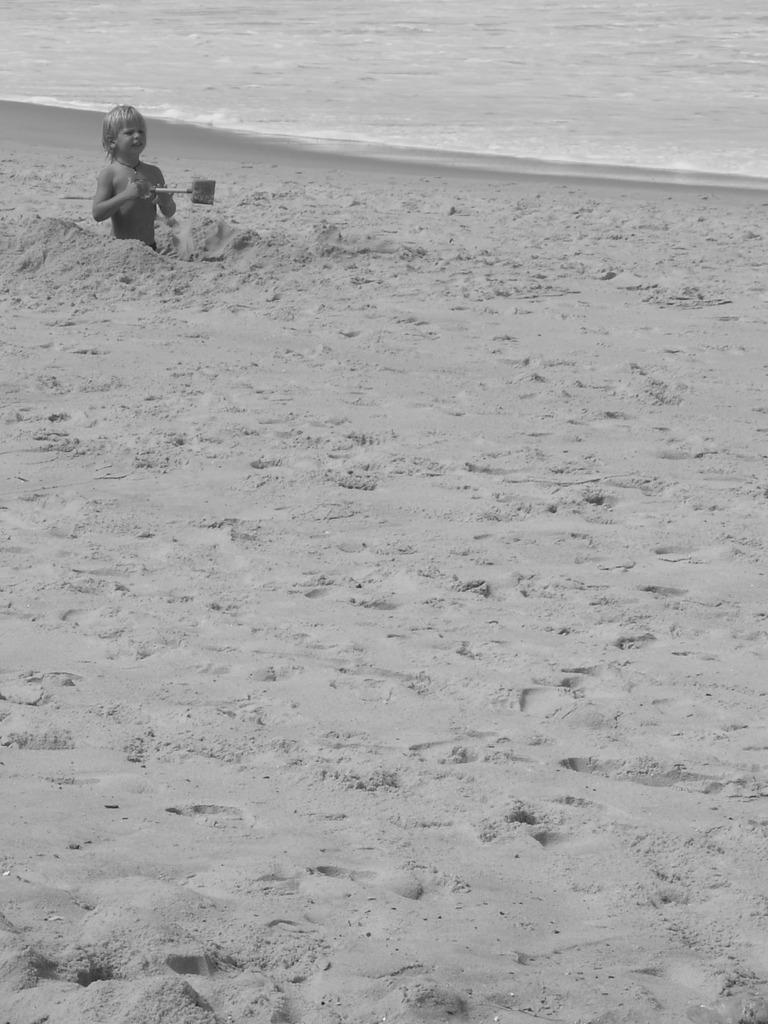Who is the main subject in the image? There is a boy in the image. What is the boy doing in the image? The boy is holding an object. What can be seen in the background of the image? There is water visible in the background of the image. What is the color scheme of the image? The image is black and white in color. What type of business is the boy celebrating his birthday at in the image? There is no indication of a business or a birthday celebration in the image; it features a boy holding an object in a black and white setting with water visible in the background. 